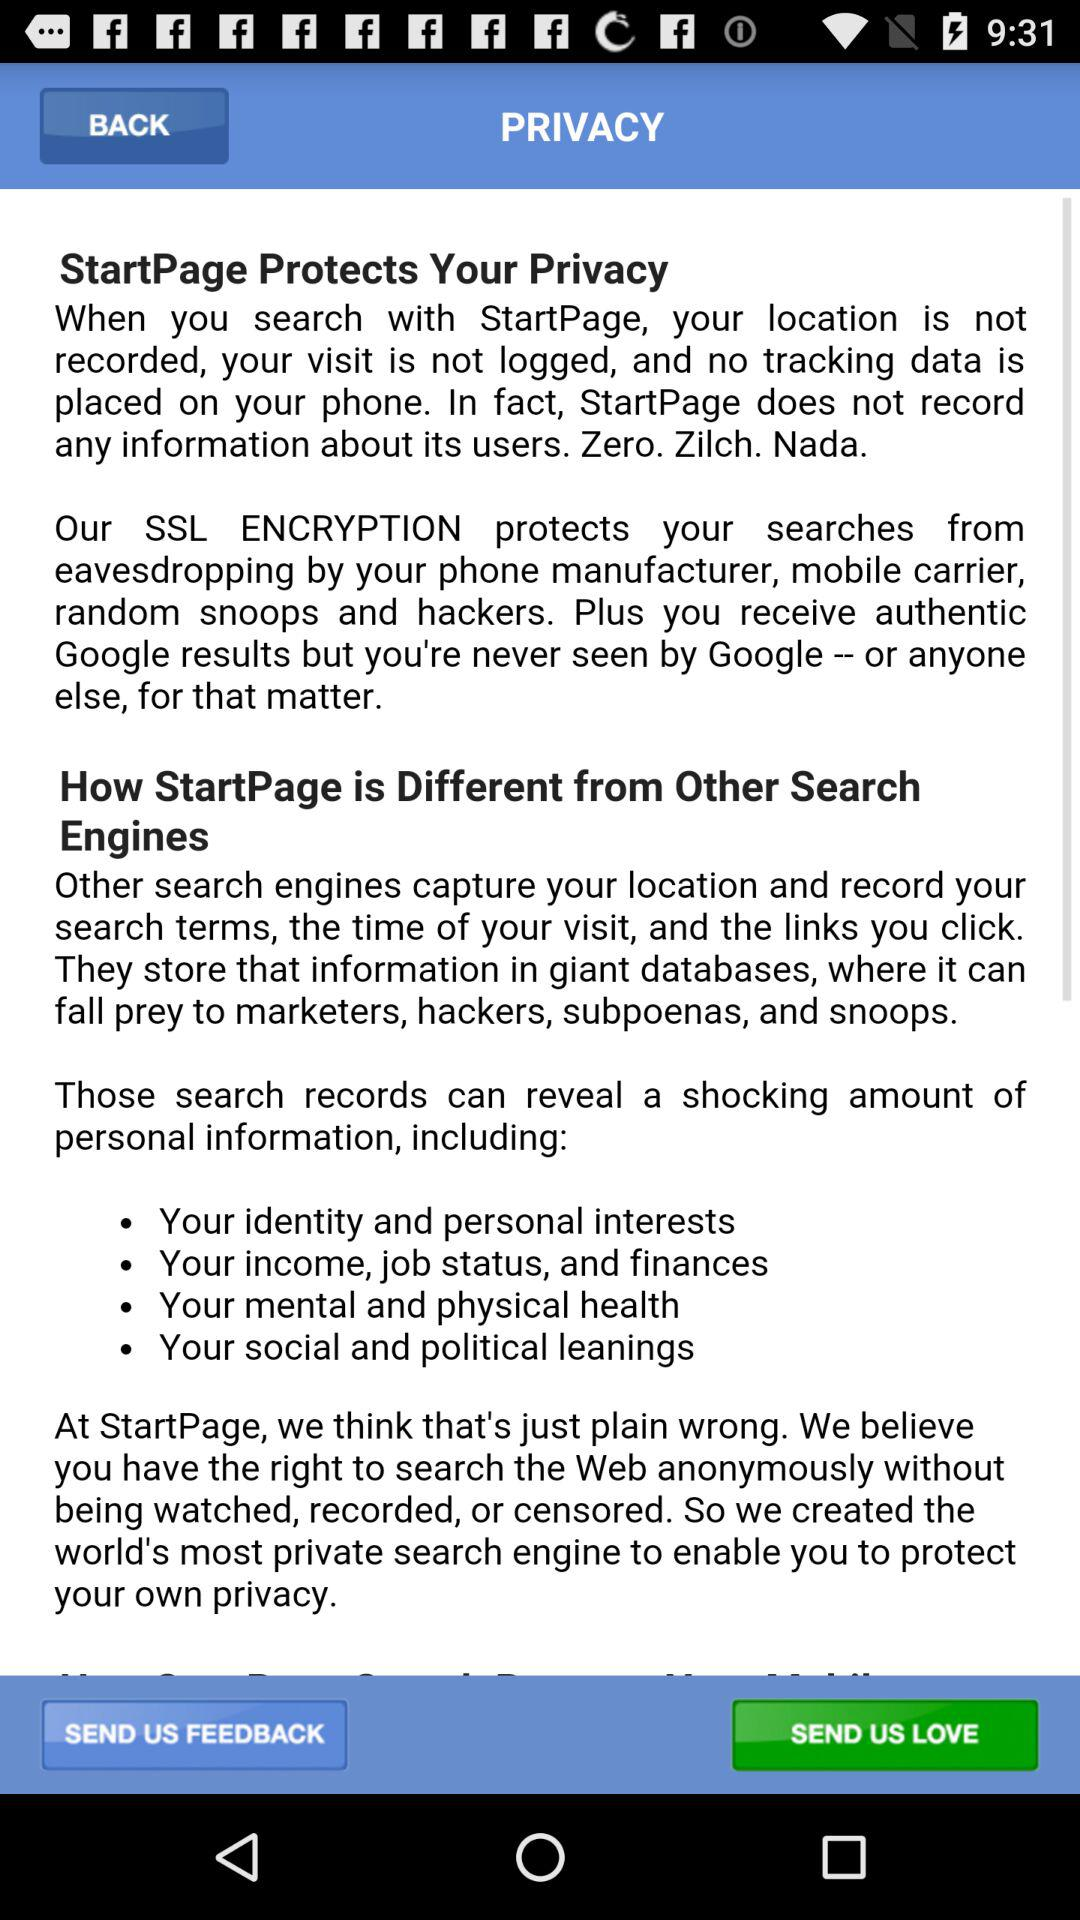What type of personal information is revealed? The types of personal information revealed are "Your identity and personal interests", "Your income, job status, and finances", "Your mental and physical health" and "Your social and political learnings". 